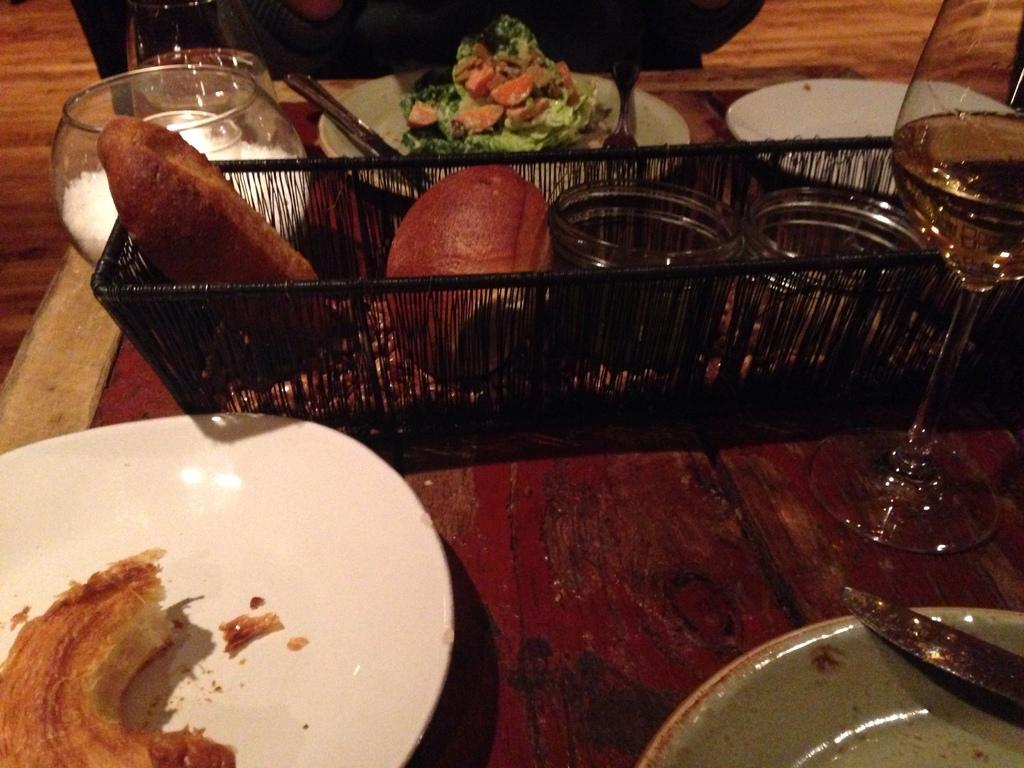What type of dishware can be seen in the image? There are plates in the image. What else is present on the table besides plates? There are food items, spoons, jars, and glasses in the image. What is the color of the table in the image? The table is brown. What can be said about the colors of the objects in the image? The objects are in different colors. Who is the owner of the table in the image? The image does not provide information about the ownership of the table. Can you tell me if there is a guide present in the image? There is no mention of a guide in the image. 